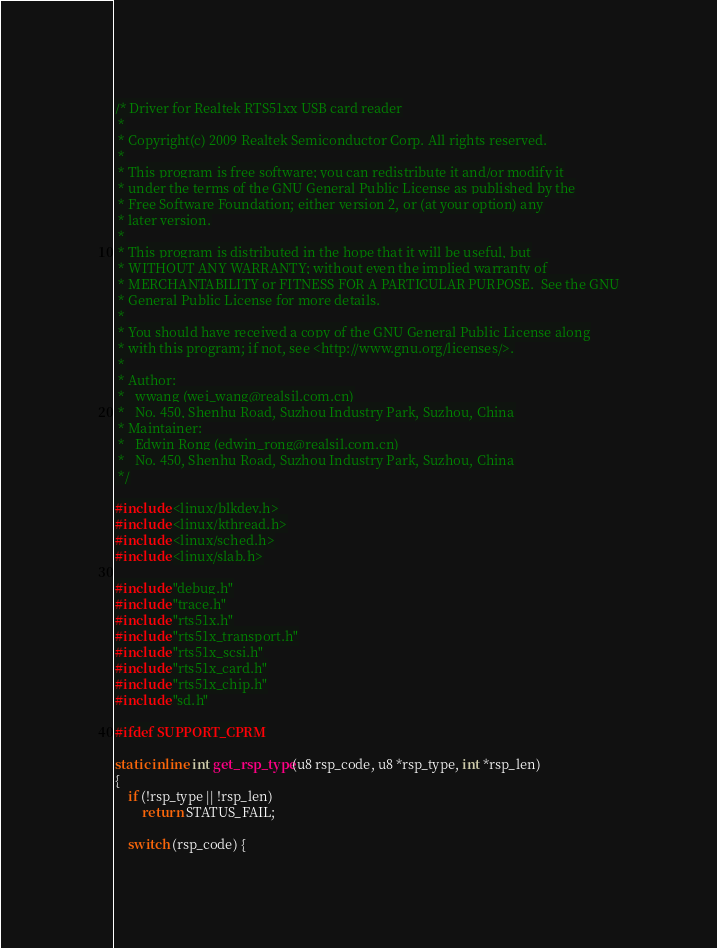Convert code to text. <code><loc_0><loc_0><loc_500><loc_500><_C_>/* Driver for Realtek RTS51xx USB card reader
 *
 * Copyright(c) 2009 Realtek Semiconductor Corp. All rights reserved.
 *
 * This program is free software; you can redistribute it and/or modify it
 * under the terms of the GNU General Public License as published by the
 * Free Software Foundation; either version 2, or (at your option) any
 * later version.
 *
 * This program is distributed in the hope that it will be useful, but
 * WITHOUT ANY WARRANTY; without even the implied warranty of
 * MERCHANTABILITY or FITNESS FOR A PARTICULAR PURPOSE.  See the GNU
 * General Public License for more details.
 *
 * You should have received a copy of the GNU General Public License along
 * with this program; if not, see <http://www.gnu.org/licenses/>.
 *
 * Author:
 *   wwang (wei_wang@realsil.com.cn)
 *   No. 450, Shenhu Road, Suzhou Industry Park, Suzhou, China
 * Maintainer:
 *   Edwin Rong (edwin_rong@realsil.com.cn)
 *   No. 450, Shenhu Road, Suzhou Industry Park, Suzhou, China
 */

#include <linux/blkdev.h>
#include <linux/kthread.h>
#include <linux/sched.h>
#include <linux/slab.h>

#include "debug.h"
#include "trace.h"
#include "rts51x.h"
#include "rts51x_transport.h"
#include "rts51x_scsi.h"
#include "rts51x_card.h"
#include "rts51x_chip.h"
#include "sd.h"

#ifdef SUPPORT_CPRM

static inline int get_rsp_type(u8 rsp_code, u8 *rsp_type, int *rsp_len)
{
	if (!rsp_type || !rsp_len)
		return STATUS_FAIL;

	switch (rsp_code) {</code> 